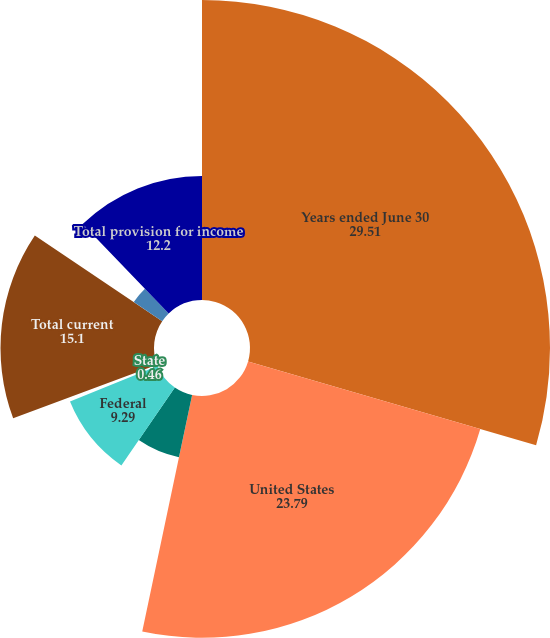Convert chart. <chart><loc_0><loc_0><loc_500><loc_500><pie_chart><fcel>Years ended June 30<fcel>United States<fcel>Foreign<fcel>Federal<fcel>State<fcel>Total current<fcel>Total deferred<fcel>Total provision for income<nl><fcel>29.51%<fcel>23.79%<fcel>6.27%<fcel>9.29%<fcel>0.46%<fcel>15.1%<fcel>3.37%<fcel>12.2%<nl></chart> 